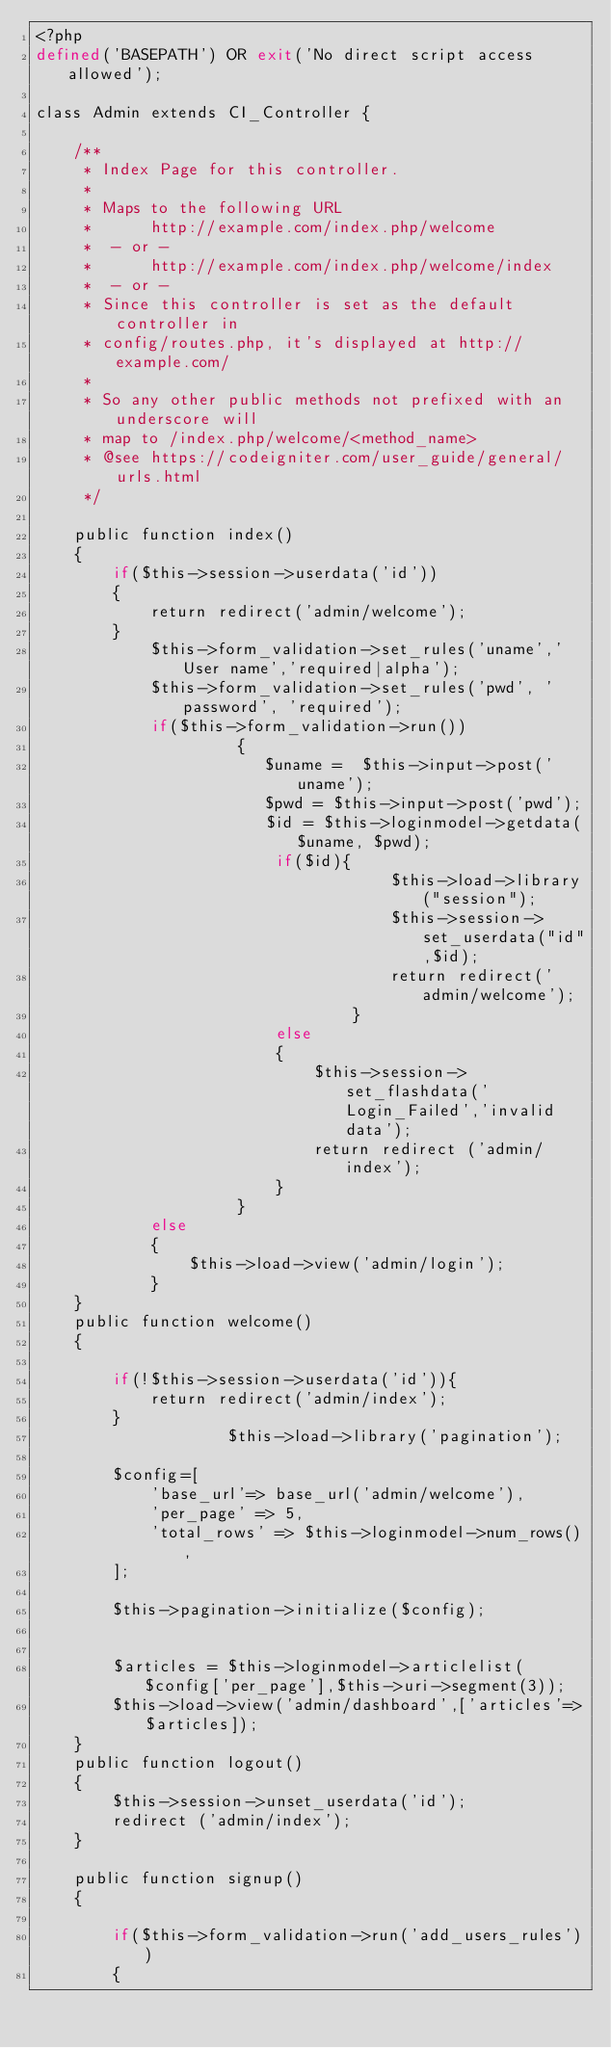<code> <loc_0><loc_0><loc_500><loc_500><_PHP_><?php
defined('BASEPATH') OR exit('No direct script access allowed');

class Admin extends CI_Controller {

	/**
	 * Index Page for this controller.
	 *
	 * Maps to the following URL
	 * 		http://example.com/index.php/welcome
	 *	- or -
	 * 		http://example.com/index.php/welcome/index
	 *	- or -
	 * Since this controller is set as the default controller in
	 * config/routes.php, it's displayed at http://example.com/
	 *
	 * So any other public methods not prefixed with an underscore will
	 * map to /index.php/welcome/<method_name>
	 * @see https://codeigniter.com/user_guide/general/urls.html
	 */

	public function index()
	{
		if($this->session->userdata('id'))
		{
			return redirect('admin/welcome');
		}
	 		$this->form_validation->set_rules('uname','User name','required|alpha');
			$this->form_validation->set_rules('pwd', 'password', 'required');
		    if($this->form_validation->run())
					 {
						$uname =  $this->input->post('uname');
						$pwd = $this->input->post('pwd');
						$id = $this->loginmodel->getdata($uname, $pwd);
						 if($id){
									 $this->load->library("session");
									 $this->session->set_userdata("id",$id);
									 return redirect('admin/welcome');
								 }
						 else
						 {
							 $this->session->set_flashdata('Login_Failed','invalid data');	
							 return redirect ('admin/index');
						 }
					 }
	 		else
	 		{
		 		$this->load->view('admin/login');
	 		}
	}
	public function welcome()
	{
		
		if(!$this->session->userdata('id')){
			return redirect('admin/index');
		}
					$this->load->library('pagination');

		$config=[
			'base_url'=> base_url('admin/welcome'),
			'per_page' => 5,
			'total_rows' => $this->loginmodel->num_rows(),
		];

		$this->pagination->initialize($config);


		$articles = $this->loginmodel->articlelist($config['per_page'],$this->uri->segment(3));
		$this->load->view('admin/dashboard',['articles'=>$articles]);
	}
	public function logout()
	{
		$this->session->unset_userdata('id');
		redirect ('admin/index');
	}

	public function signup()
	{
		
		if($this->form_validation->run('add_users_rules'))
		{</code> 